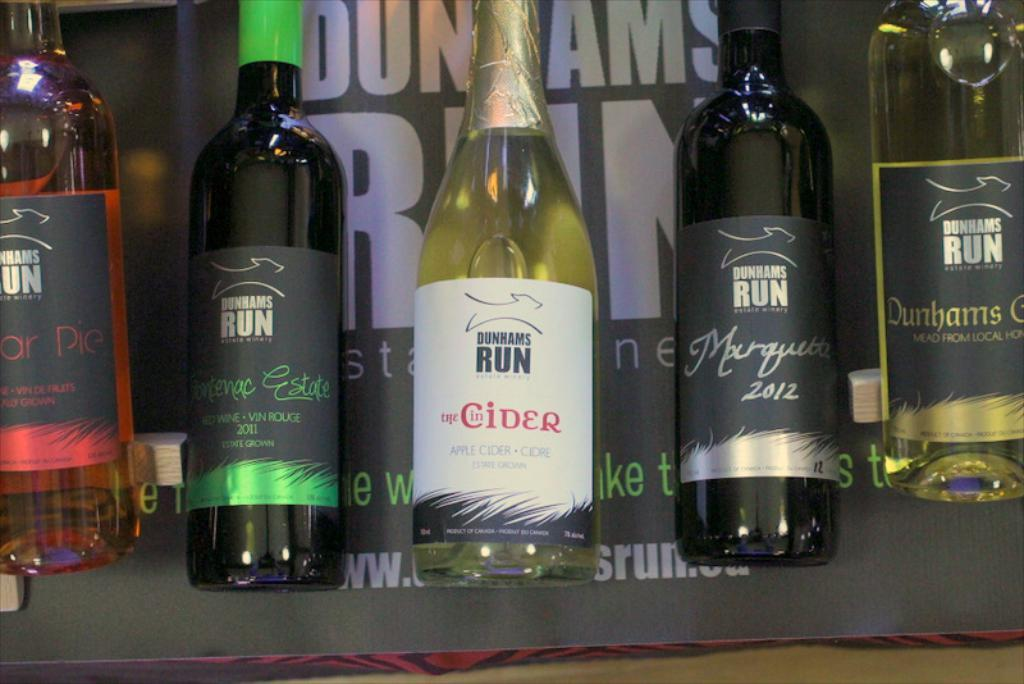Provide a one-sentence caption for the provided image. A selection of different types of wine and apple cider made by the company Dunhams Run. 